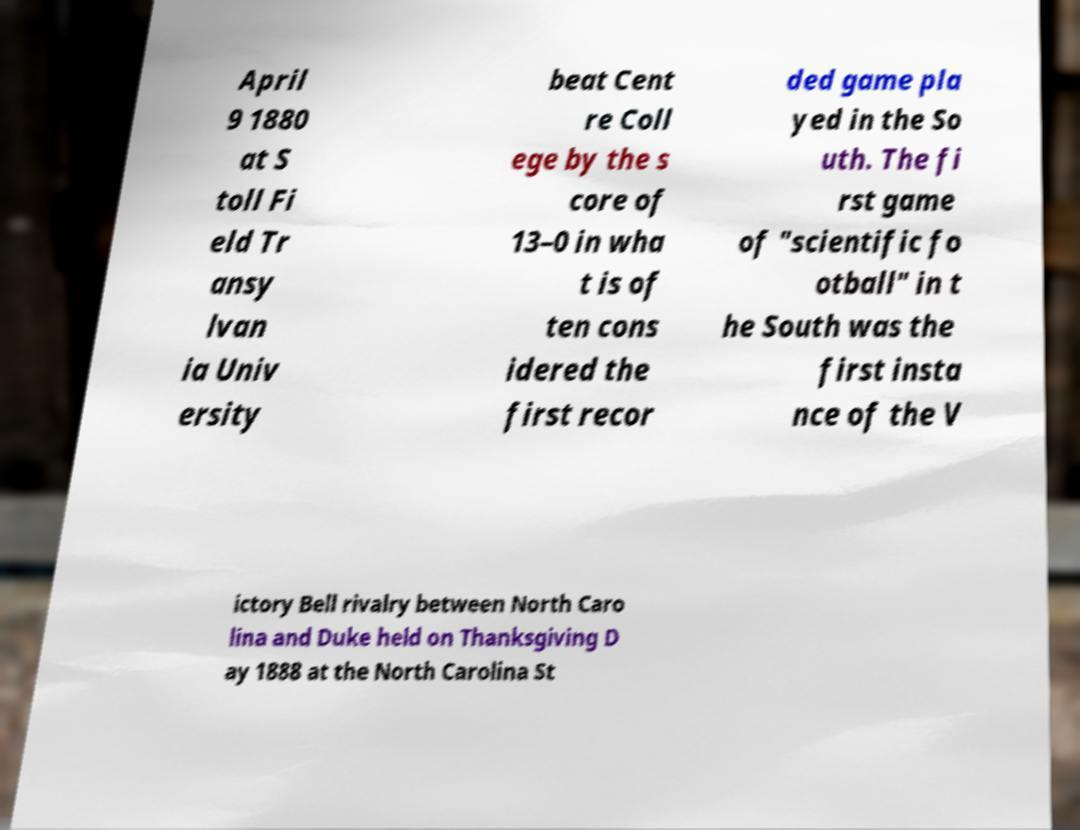For documentation purposes, I need the text within this image transcribed. Could you provide that? April 9 1880 at S toll Fi eld Tr ansy lvan ia Univ ersity beat Cent re Coll ege by the s core of 13–0 in wha t is of ten cons idered the first recor ded game pla yed in the So uth. The fi rst game of "scientific fo otball" in t he South was the first insta nce of the V ictory Bell rivalry between North Caro lina and Duke held on Thanksgiving D ay 1888 at the North Carolina St 